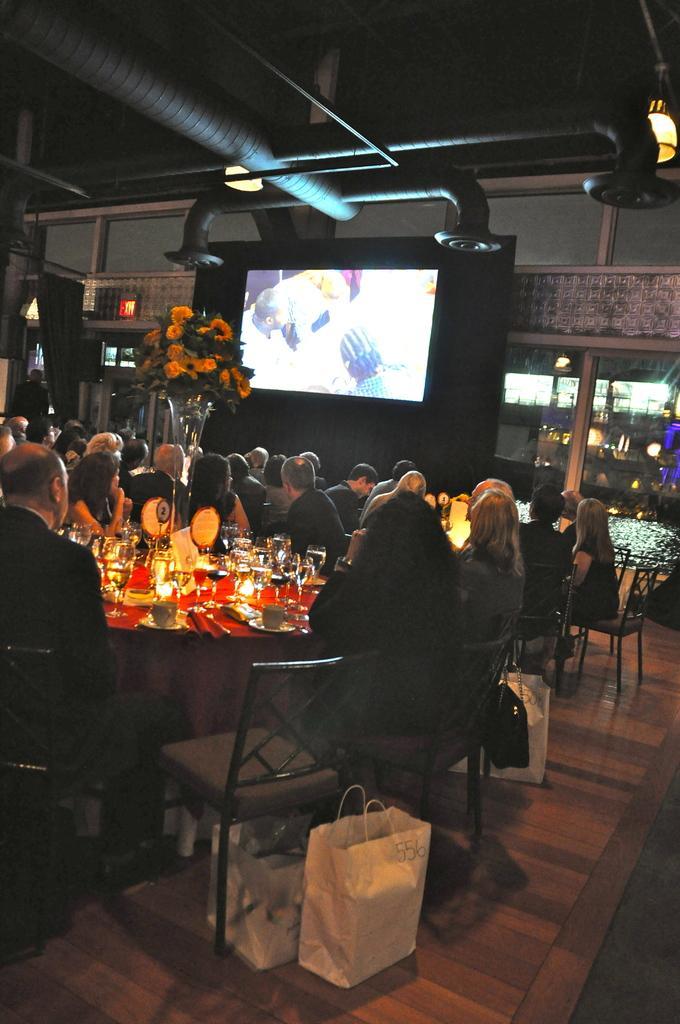Could you give a brief overview of what you see in this image? In the image I can see a place in which there are some people sitting on the chairs on which there are some plates, glasses, candles and around there is a screen, plant and some other things around. 